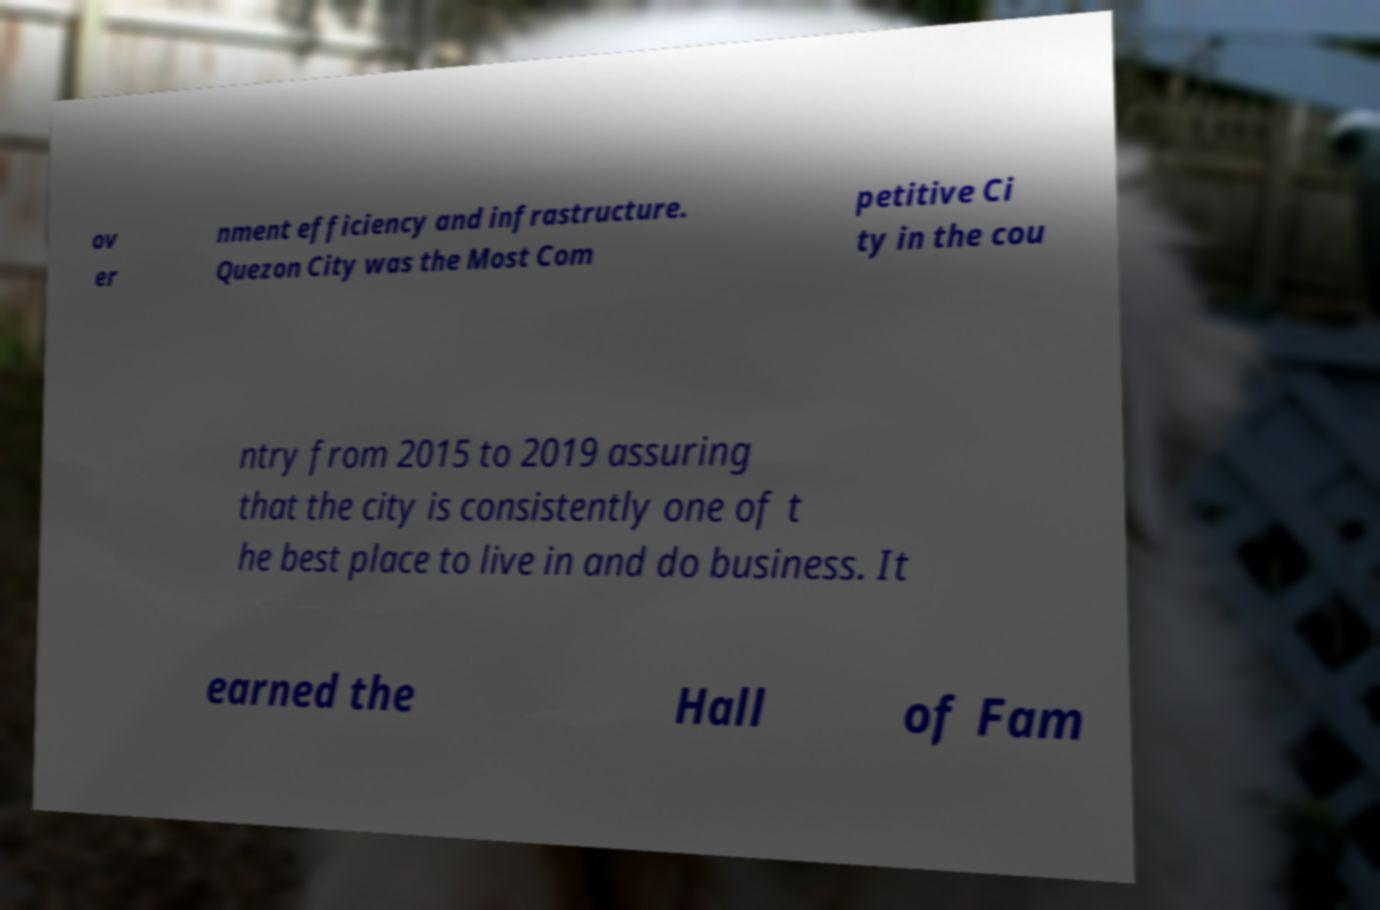What messages or text are displayed in this image? I need them in a readable, typed format. ov er nment efficiency and infrastructure. Quezon City was the Most Com petitive Ci ty in the cou ntry from 2015 to 2019 assuring that the city is consistently one of t he best place to live in and do business. It earned the Hall of Fam 